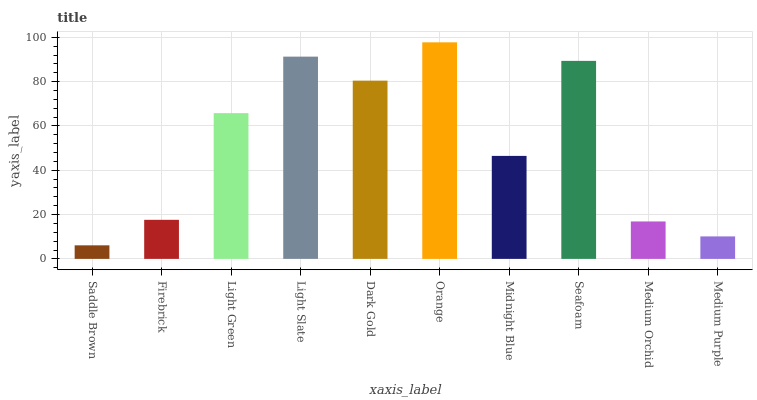Is Saddle Brown the minimum?
Answer yes or no. Yes. Is Orange the maximum?
Answer yes or no. Yes. Is Firebrick the minimum?
Answer yes or no. No. Is Firebrick the maximum?
Answer yes or no. No. Is Firebrick greater than Saddle Brown?
Answer yes or no. Yes. Is Saddle Brown less than Firebrick?
Answer yes or no. Yes. Is Saddle Brown greater than Firebrick?
Answer yes or no. No. Is Firebrick less than Saddle Brown?
Answer yes or no. No. Is Light Green the high median?
Answer yes or no. Yes. Is Midnight Blue the low median?
Answer yes or no. Yes. Is Light Slate the high median?
Answer yes or no. No. Is Light Slate the low median?
Answer yes or no. No. 